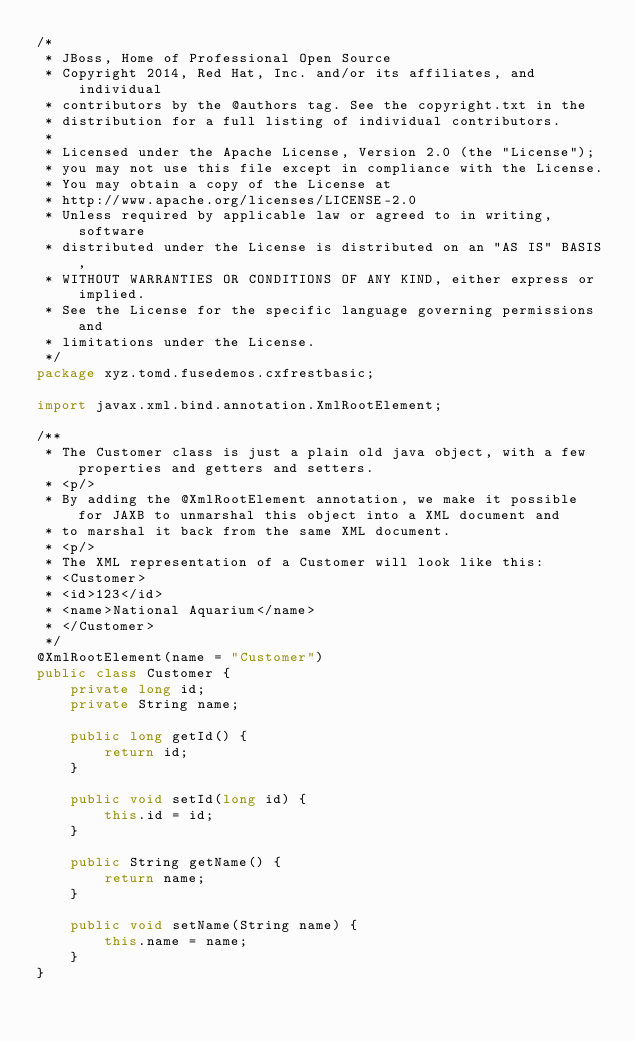Convert code to text. <code><loc_0><loc_0><loc_500><loc_500><_Java_>/*
 * JBoss, Home of Professional Open Source
 * Copyright 2014, Red Hat, Inc. and/or its affiliates, and individual
 * contributors by the @authors tag. See the copyright.txt in the
 * distribution for a full listing of individual contributors.
 *
 * Licensed under the Apache License, Version 2.0 (the "License");
 * you may not use this file except in compliance with the License.
 * You may obtain a copy of the License at
 * http://www.apache.org/licenses/LICENSE-2.0
 * Unless required by applicable law or agreed to in writing, software
 * distributed under the License is distributed on an "AS IS" BASIS,
 * WITHOUT WARRANTIES OR CONDITIONS OF ANY KIND, either express or implied.
 * See the License for the specific language governing permissions and
 * limitations under the License.
 */
package xyz.tomd.fusedemos.cxfrestbasic;

import javax.xml.bind.annotation.XmlRootElement;

/**
 * The Customer class is just a plain old java object, with a few properties and getters and setters.
 * <p/>
 * By adding the @XmlRootElement annotation, we make it possible for JAXB to unmarshal this object into a XML document and
 * to marshal it back from the same XML document.
 * <p/>
 * The XML representation of a Customer will look like this:
 * <Customer>
 * <id>123</id>
 * <name>National Aquarium</name>
 * </Customer>
 */
@XmlRootElement(name = "Customer")
public class Customer {
    private long id;
    private String name;

    public long getId() {
        return id;
    }

    public void setId(long id) {
        this.id = id;
    }

    public String getName() {
        return name;
    }

    public void setName(String name) {
        this.name = name;
    }
}
</code> 